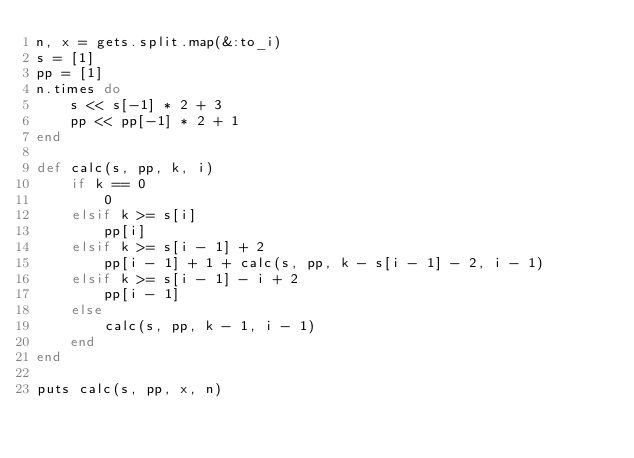Convert code to text. <code><loc_0><loc_0><loc_500><loc_500><_Ruby_>n, x = gets.split.map(&:to_i)
s = [1]
pp = [1]
n.times do 
    s << s[-1] * 2 + 3
    pp << pp[-1] * 2 + 1
end

def calc(s, pp, k, i)
    if k == 0
        0
    elsif k >= s[i]
        pp[i]
    elsif k >= s[i - 1] + 2
        pp[i - 1] + 1 + calc(s, pp, k - s[i - 1] - 2, i - 1)
    elsif k >= s[i - 1] - i + 2
        pp[i - 1]
    else
        calc(s, pp, k - 1, i - 1)
    end
end

puts calc(s, pp, x, n)</code> 